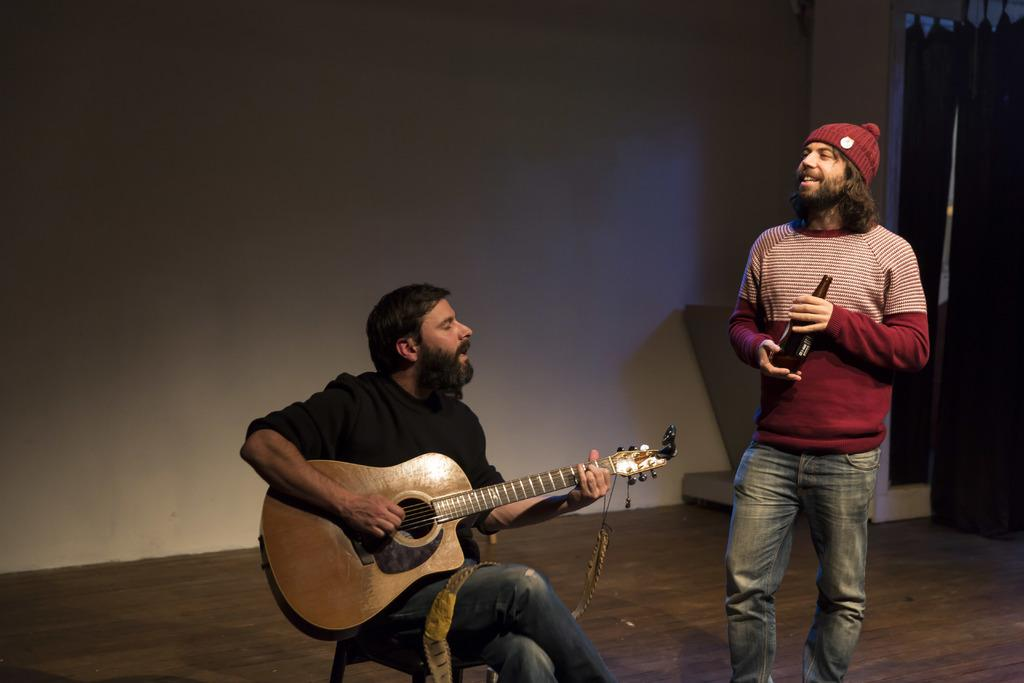What can be seen in the background of the image? There is a wall in the image. How many people are present in the image? There are two people in the image. What is one of the people doing? One of the people is sitting and holding a guitar. What is the other person holding? The other person is holding a bottle. What type of wire is being used to hold the pickle in the image? There is no pickle present in the image, and therefore no wire is being used to hold it. What type of linen is draped over the guitar in the image? There is no linen draped over the guitar in the image. 